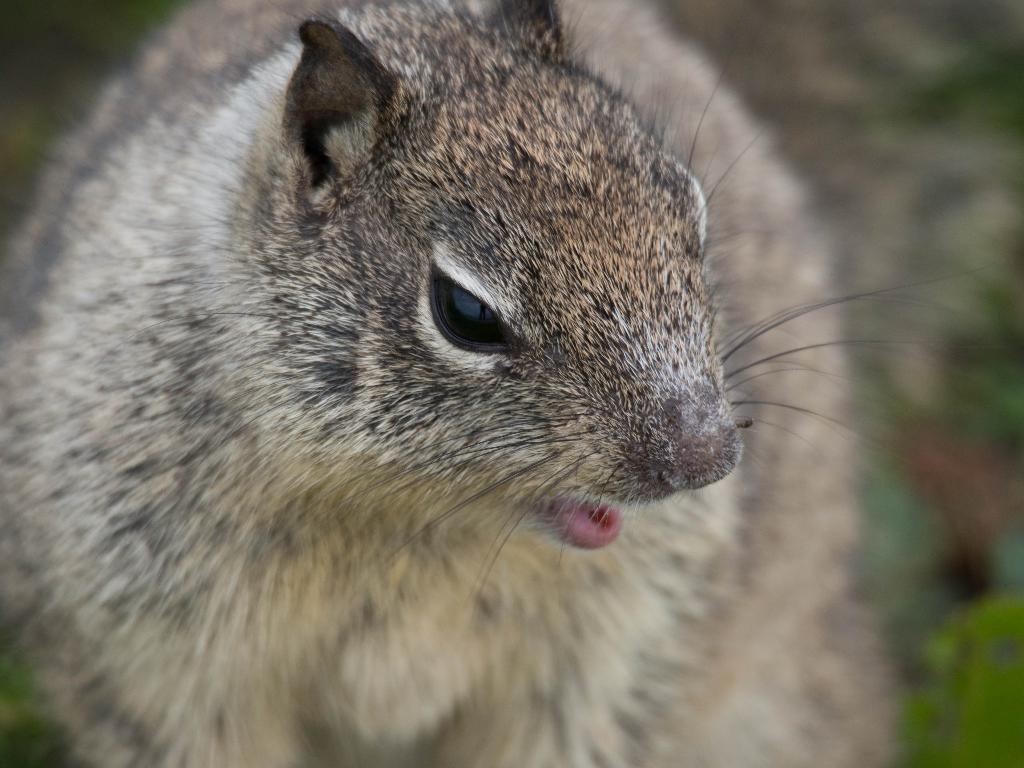What type of animal is in the image? The specific type of animal cannot be determined from the provided facts. Can you describe the background of the image? The background of the image is blurred. What emotions can be seen on the animal's face in the image? The provided facts do not mention any emotions or facial expressions of the animal. 